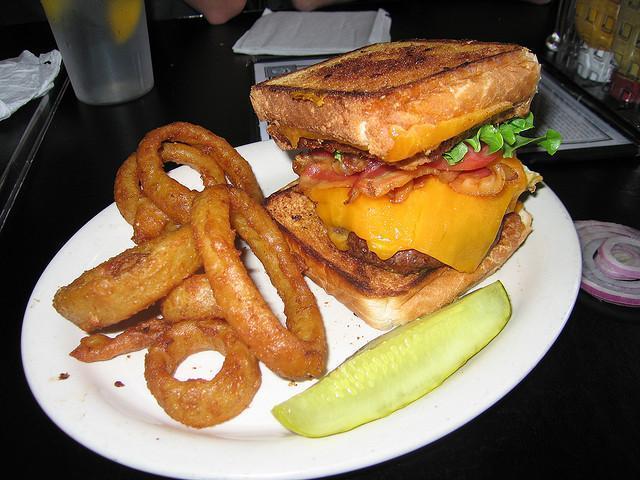How many onion rings are there?
Give a very brief answer. 6. How many knives are in the picture?
Give a very brief answer. 1. 